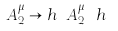Convert formula to latex. <formula><loc_0><loc_0><loc_500><loc_500>A _ { 2 } ^ { \mu } \rightarrow h \ A _ { 2 } ^ { \mu } \ h ^ { \dagger }</formula> 